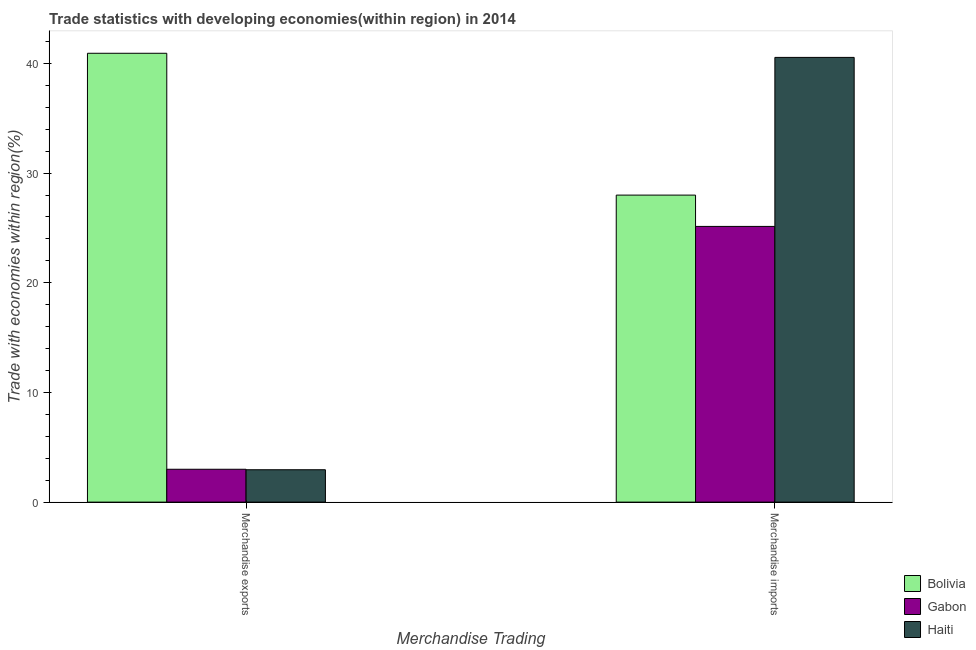How many groups of bars are there?
Keep it short and to the point. 2. Are the number of bars per tick equal to the number of legend labels?
Provide a short and direct response. Yes. How many bars are there on the 2nd tick from the right?
Your response must be concise. 3. What is the merchandise imports in Haiti?
Your response must be concise. 40.55. Across all countries, what is the maximum merchandise imports?
Keep it short and to the point. 40.55. Across all countries, what is the minimum merchandise imports?
Ensure brevity in your answer.  25.14. In which country was the merchandise imports maximum?
Offer a terse response. Haiti. In which country was the merchandise exports minimum?
Your response must be concise. Haiti. What is the total merchandise exports in the graph?
Your response must be concise. 46.87. What is the difference between the merchandise exports in Bolivia and that in Haiti?
Make the answer very short. 37.97. What is the difference between the merchandise exports in Bolivia and the merchandise imports in Haiti?
Your answer should be compact. 0.38. What is the average merchandise imports per country?
Your answer should be compact. 31.23. What is the difference between the merchandise exports and merchandise imports in Gabon?
Ensure brevity in your answer.  -22.14. What is the ratio of the merchandise exports in Gabon to that in Bolivia?
Your response must be concise. 0.07. In how many countries, is the merchandise imports greater than the average merchandise imports taken over all countries?
Provide a succinct answer. 1. What does the 2nd bar from the left in Merchandise imports represents?
Give a very brief answer. Gabon. What does the 1st bar from the right in Merchandise imports represents?
Ensure brevity in your answer.  Haiti. Are all the bars in the graph horizontal?
Offer a very short reply. No. How many countries are there in the graph?
Offer a terse response. 3. Are the values on the major ticks of Y-axis written in scientific E-notation?
Offer a very short reply. No. Does the graph contain grids?
Offer a terse response. No. Where does the legend appear in the graph?
Your response must be concise. Bottom right. How many legend labels are there?
Offer a terse response. 3. What is the title of the graph?
Offer a very short reply. Trade statistics with developing economies(within region) in 2014. What is the label or title of the X-axis?
Offer a terse response. Merchandise Trading. What is the label or title of the Y-axis?
Your answer should be very brief. Trade with economies within region(%). What is the Trade with economies within region(%) of Bolivia in Merchandise exports?
Ensure brevity in your answer.  40.92. What is the Trade with economies within region(%) of Gabon in Merchandise exports?
Keep it short and to the point. 3. What is the Trade with economies within region(%) in Haiti in Merchandise exports?
Keep it short and to the point. 2.95. What is the Trade with economies within region(%) in Bolivia in Merchandise imports?
Your response must be concise. 27.99. What is the Trade with economies within region(%) of Gabon in Merchandise imports?
Ensure brevity in your answer.  25.14. What is the Trade with economies within region(%) of Haiti in Merchandise imports?
Keep it short and to the point. 40.55. Across all Merchandise Trading, what is the maximum Trade with economies within region(%) in Bolivia?
Keep it short and to the point. 40.92. Across all Merchandise Trading, what is the maximum Trade with economies within region(%) in Gabon?
Offer a very short reply. 25.14. Across all Merchandise Trading, what is the maximum Trade with economies within region(%) of Haiti?
Provide a short and direct response. 40.55. Across all Merchandise Trading, what is the minimum Trade with economies within region(%) of Bolivia?
Provide a succinct answer. 27.99. Across all Merchandise Trading, what is the minimum Trade with economies within region(%) in Gabon?
Give a very brief answer. 3. Across all Merchandise Trading, what is the minimum Trade with economies within region(%) in Haiti?
Ensure brevity in your answer.  2.95. What is the total Trade with economies within region(%) in Bolivia in the graph?
Your response must be concise. 68.92. What is the total Trade with economies within region(%) in Gabon in the graph?
Ensure brevity in your answer.  28.13. What is the total Trade with economies within region(%) of Haiti in the graph?
Provide a succinct answer. 43.5. What is the difference between the Trade with economies within region(%) of Bolivia in Merchandise exports and that in Merchandise imports?
Offer a terse response. 12.93. What is the difference between the Trade with economies within region(%) of Gabon in Merchandise exports and that in Merchandise imports?
Your answer should be compact. -22.14. What is the difference between the Trade with economies within region(%) in Haiti in Merchandise exports and that in Merchandise imports?
Give a very brief answer. -37.59. What is the difference between the Trade with economies within region(%) in Bolivia in Merchandise exports and the Trade with economies within region(%) in Gabon in Merchandise imports?
Provide a short and direct response. 15.79. What is the difference between the Trade with economies within region(%) in Bolivia in Merchandise exports and the Trade with economies within region(%) in Haiti in Merchandise imports?
Provide a short and direct response. 0.38. What is the difference between the Trade with economies within region(%) in Gabon in Merchandise exports and the Trade with economies within region(%) in Haiti in Merchandise imports?
Provide a short and direct response. -37.55. What is the average Trade with economies within region(%) of Bolivia per Merchandise Trading?
Offer a very short reply. 34.46. What is the average Trade with economies within region(%) in Gabon per Merchandise Trading?
Offer a very short reply. 14.07. What is the average Trade with economies within region(%) of Haiti per Merchandise Trading?
Offer a very short reply. 21.75. What is the difference between the Trade with economies within region(%) of Bolivia and Trade with economies within region(%) of Gabon in Merchandise exports?
Provide a short and direct response. 37.93. What is the difference between the Trade with economies within region(%) in Bolivia and Trade with economies within region(%) in Haiti in Merchandise exports?
Ensure brevity in your answer.  37.97. What is the difference between the Trade with economies within region(%) of Gabon and Trade with economies within region(%) of Haiti in Merchandise exports?
Your answer should be compact. 0.04. What is the difference between the Trade with economies within region(%) of Bolivia and Trade with economies within region(%) of Gabon in Merchandise imports?
Provide a succinct answer. 2.85. What is the difference between the Trade with economies within region(%) of Bolivia and Trade with economies within region(%) of Haiti in Merchandise imports?
Offer a very short reply. -12.55. What is the difference between the Trade with economies within region(%) in Gabon and Trade with economies within region(%) in Haiti in Merchandise imports?
Ensure brevity in your answer.  -15.41. What is the ratio of the Trade with economies within region(%) of Bolivia in Merchandise exports to that in Merchandise imports?
Keep it short and to the point. 1.46. What is the ratio of the Trade with economies within region(%) in Gabon in Merchandise exports to that in Merchandise imports?
Give a very brief answer. 0.12. What is the ratio of the Trade with economies within region(%) in Haiti in Merchandise exports to that in Merchandise imports?
Keep it short and to the point. 0.07. What is the difference between the highest and the second highest Trade with economies within region(%) of Bolivia?
Ensure brevity in your answer.  12.93. What is the difference between the highest and the second highest Trade with economies within region(%) of Gabon?
Your answer should be very brief. 22.14. What is the difference between the highest and the second highest Trade with economies within region(%) of Haiti?
Give a very brief answer. 37.59. What is the difference between the highest and the lowest Trade with economies within region(%) in Bolivia?
Give a very brief answer. 12.93. What is the difference between the highest and the lowest Trade with economies within region(%) of Gabon?
Your response must be concise. 22.14. What is the difference between the highest and the lowest Trade with economies within region(%) of Haiti?
Make the answer very short. 37.59. 